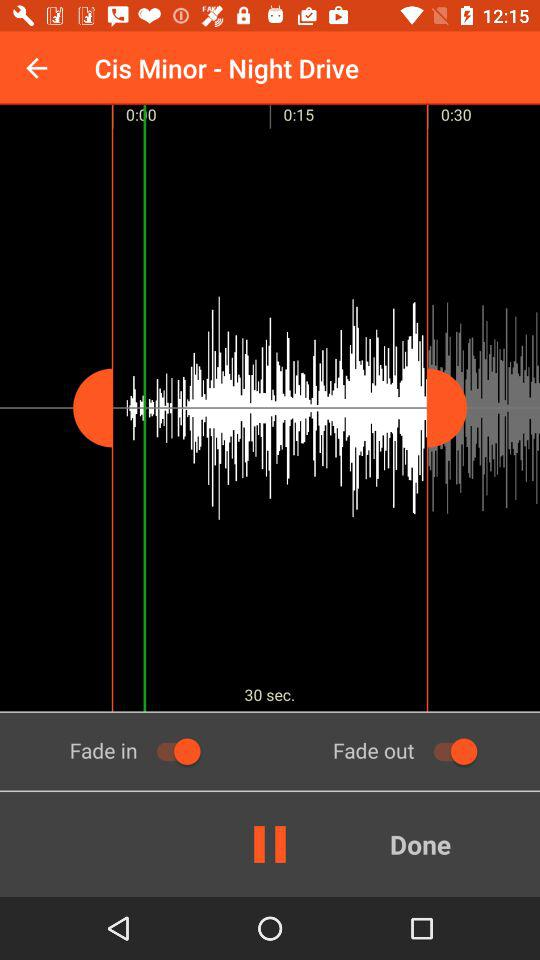What is the status of "Fade out"? The status of "Fade out" is on. 